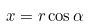<formula> <loc_0><loc_0><loc_500><loc_500>x = r \cos \alpha</formula> 